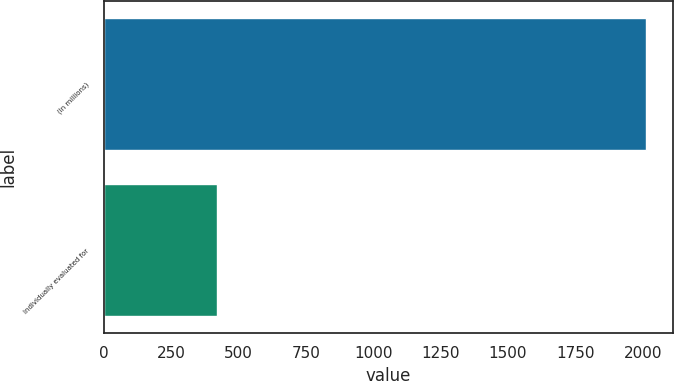<chart> <loc_0><loc_0><loc_500><loc_500><bar_chart><fcel>(In millions)<fcel>Individually evaluated for<nl><fcel>2012<fcel>422<nl></chart> 